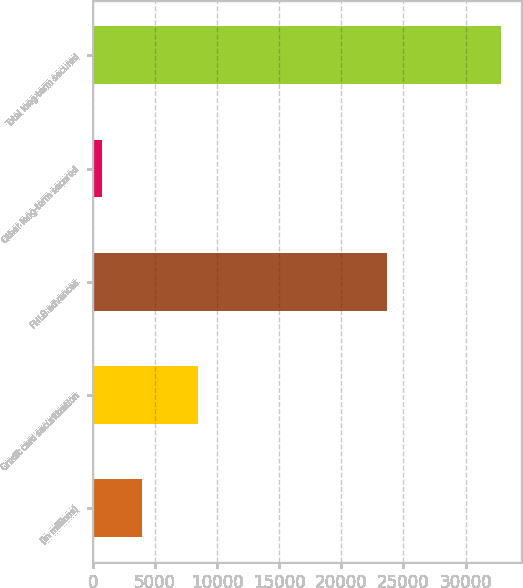<chart> <loc_0><loc_0><loc_500><loc_500><bar_chart><fcel>(in millions)<fcel>Credit card securitization<fcel>FHLB advances<fcel>Other long-term secured<fcel>Total long-term secured<nl><fcel>3959.4<fcel>8434<fcel>23650<fcel>751<fcel>32835<nl></chart> 